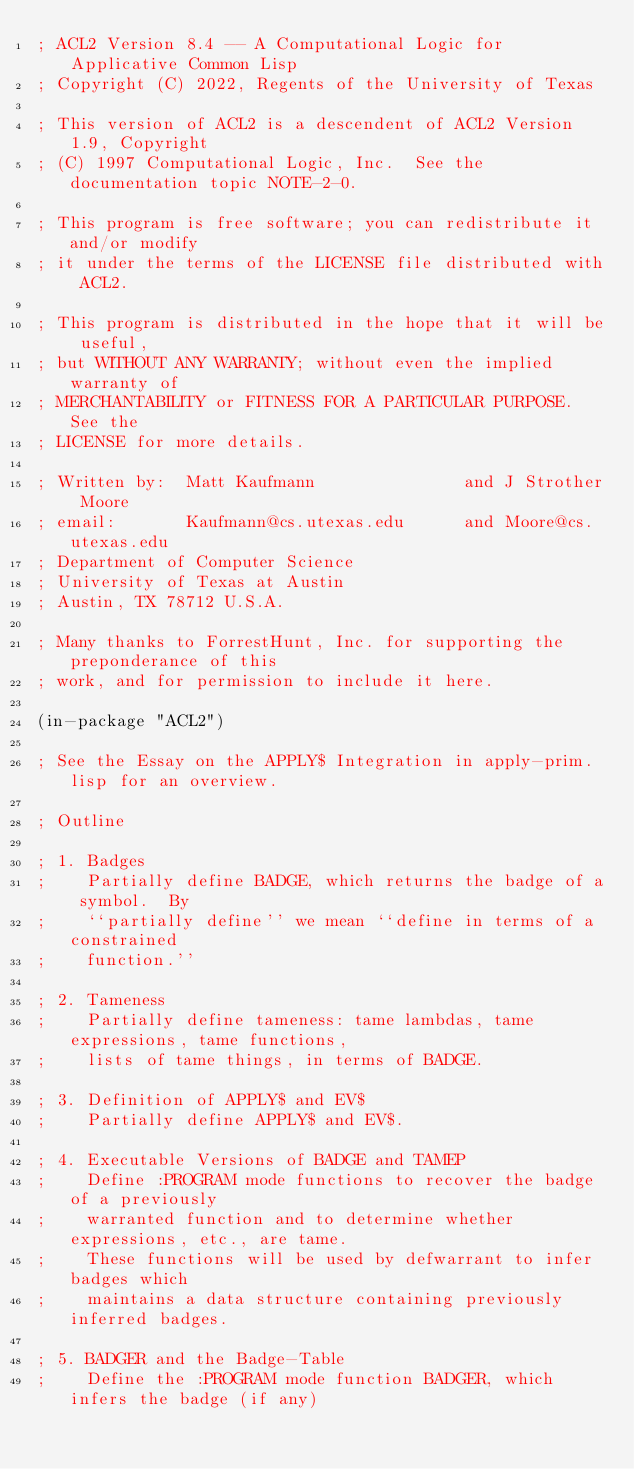Convert code to text. <code><loc_0><loc_0><loc_500><loc_500><_Lisp_>; ACL2 Version 8.4 -- A Computational Logic for Applicative Common Lisp
; Copyright (C) 2022, Regents of the University of Texas

; This version of ACL2 is a descendent of ACL2 Version 1.9, Copyright
; (C) 1997 Computational Logic, Inc.  See the documentation topic NOTE-2-0.

; This program is free software; you can redistribute it and/or modify
; it under the terms of the LICENSE file distributed with ACL2.

; This program is distributed in the hope that it will be useful,
; but WITHOUT ANY WARRANTY; without even the implied warranty of
; MERCHANTABILITY or FITNESS FOR A PARTICULAR PURPOSE.  See the
; LICENSE for more details.

; Written by:  Matt Kaufmann               and J Strother Moore
; email:       Kaufmann@cs.utexas.edu      and Moore@cs.utexas.edu
; Department of Computer Science
; University of Texas at Austin
; Austin, TX 78712 U.S.A.

; Many thanks to ForrestHunt, Inc. for supporting the preponderance of this
; work, and for permission to include it here.

(in-package "ACL2")

; See the Essay on the APPLY$ Integration in apply-prim.lisp for an overview.

; Outline

; 1. Badges
;    Partially define BADGE, which returns the badge of a symbol.  By
;    ``partially define'' we mean ``define in terms of a constrained
;    function.''

; 2. Tameness
;    Partially define tameness: tame lambdas, tame expressions, tame functions,
;    lists of tame things, in terms of BADGE.

; 3. Definition of APPLY$ and EV$
;    Partially define APPLY$ and EV$.

; 4. Executable Versions of BADGE and TAMEP
;    Define :PROGRAM mode functions to recover the badge of a previously
;    warranted function and to determine whether expressions, etc., are tame.
;    These functions will be used by defwarrant to infer badges which
;    maintains a data structure containing previously inferred badges.

; 5. BADGER and the Badge-Table
;    Define the :PROGRAM mode function BADGER, which infers the badge (if any)</code> 